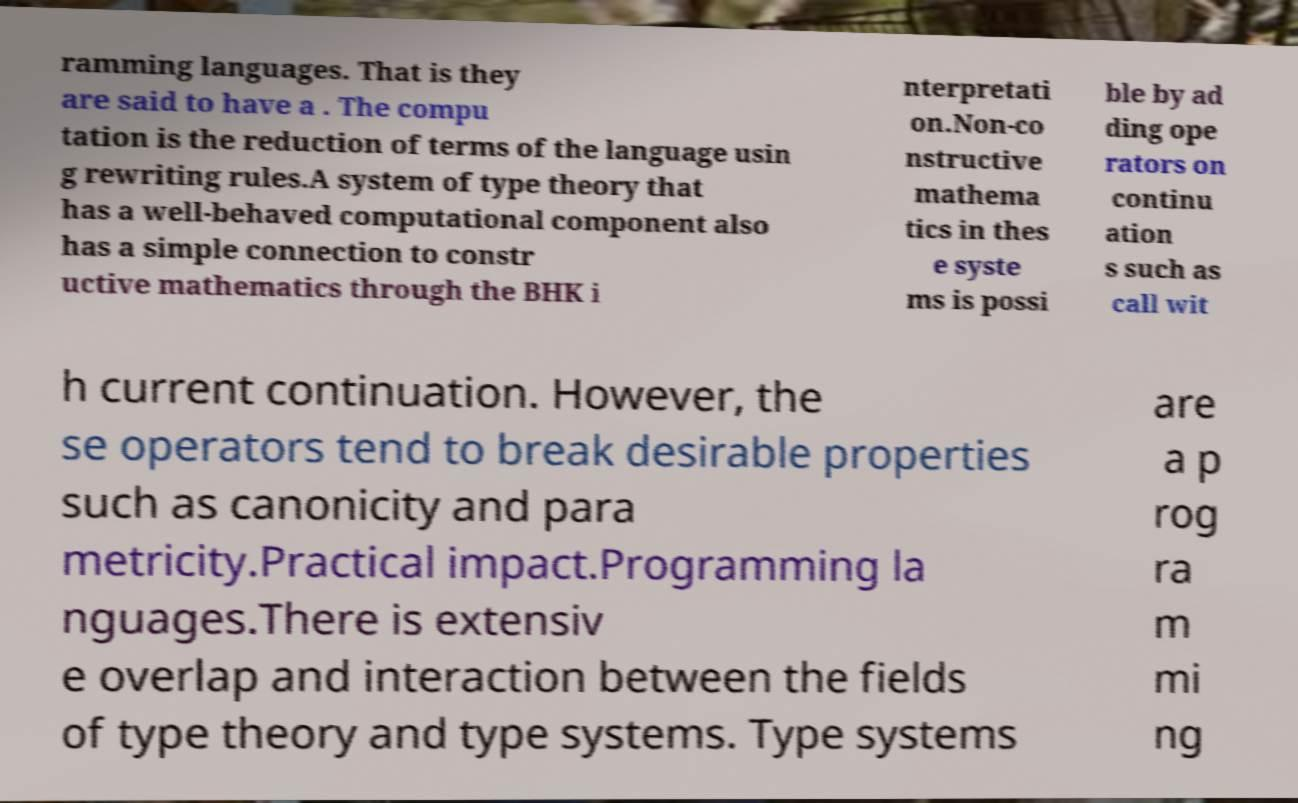Could you extract and type out the text from this image? ramming languages. That is they are said to have a . The compu tation is the reduction of terms of the language usin g rewriting rules.A system of type theory that has a well-behaved computational component also has a simple connection to constr uctive mathematics through the BHK i nterpretati on.Non-co nstructive mathema tics in thes e syste ms is possi ble by ad ding ope rators on continu ation s such as call wit h current continuation. However, the se operators tend to break desirable properties such as canonicity and para metricity.Practical impact.Programming la nguages.There is extensiv e overlap and interaction between the fields of type theory and type systems. Type systems are a p rog ra m mi ng 